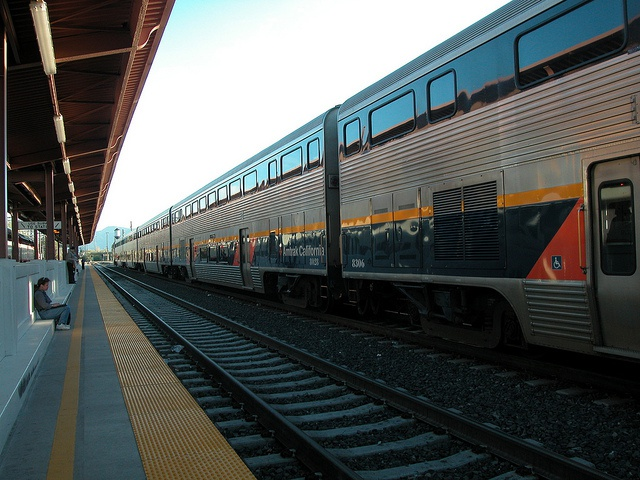Describe the objects in this image and their specific colors. I can see train in black, gray, and darkgray tones, people in black, blue, darkblue, and gray tones, people in black, purple, gray, and navy tones, and people in black and gray tones in this image. 